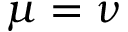Convert formula to latex. <formula><loc_0><loc_0><loc_500><loc_500>\mu = \nu</formula> 